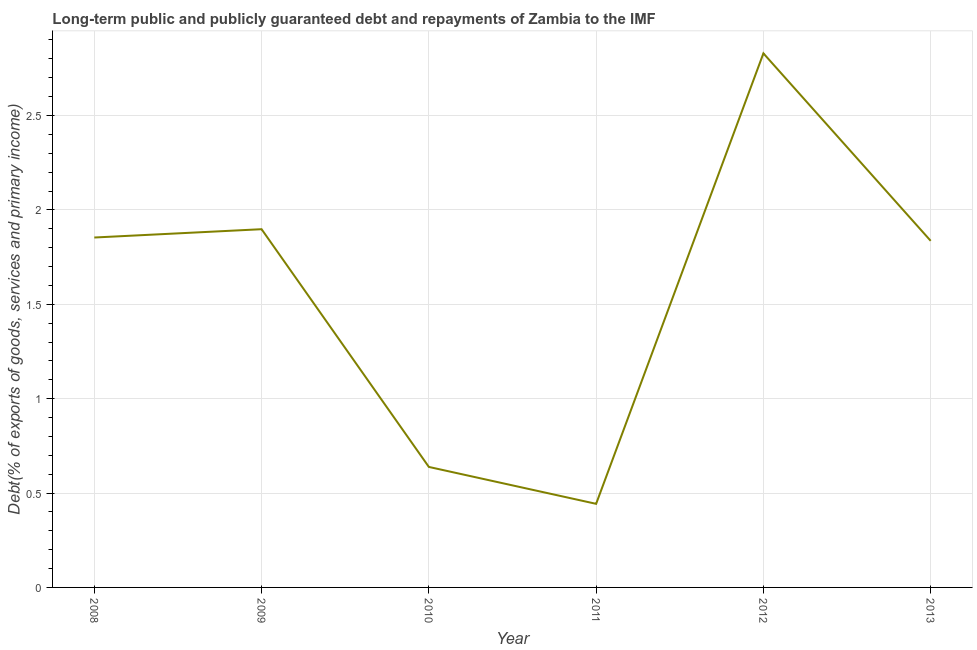What is the debt service in 2011?
Ensure brevity in your answer.  0.44. Across all years, what is the maximum debt service?
Your response must be concise. 2.83. Across all years, what is the minimum debt service?
Make the answer very short. 0.44. In which year was the debt service maximum?
Offer a terse response. 2012. What is the sum of the debt service?
Offer a terse response. 9.5. What is the difference between the debt service in 2011 and 2012?
Make the answer very short. -2.39. What is the average debt service per year?
Provide a short and direct response. 1.58. What is the median debt service?
Offer a very short reply. 1.84. Do a majority of the years between 2009 and 2008 (inclusive) have debt service greater than 0.1 %?
Give a very brief answer. No. What is the ratio of the debt service in 2008 to that in 2012?
Provide a short and direct response. 0.66. Is the debt service in 2010 less than that in 2012?
Make the answer very short. Yes. Is the difference between the debt service in 2009 and 2011 greater than the difference between any two years?
Your answer should be very brief. No. What is the difference between the highest and the second highest debt service?
Your response must be concise. 0.93. Is the sum of the debt service in 2010 and 2013 greater than the maximum debt service across all years?
Give a very brief answer. No. What is the difference between the highest and the lowest debt service?
Your answer should be compact. 2.39. In how many years, is the debt service greater than the average debt service taken over all years?
Make the answer very short. 4. How many years are there in the graph?
Provide a short and direct response. 6. Are the values on the major ticks of Y-axis written in scientific E-notation?
Your response must be concise. No. Does the graph contain grids?
Provide a succinct answer. Yes. What is the title of the graph?
Your answer should be compact. Long-term public and publicly guaranteed debt and repayments of Zambia to the IMF. What is the label or title of the Y-axis?
Keep it short and to the point. Debt(% of exports of goods, services and primary income). What is the Debt(% of exports of goods, services and primary income) of 2008?
Keep it short and to the point. 1.85. What is the Debt(% of exports of goods, services and primary income) of 2009?
Give a very brief answer. 1.9. What is the Debt(% of exports of goods, services and primary income) of 2010?
Give a very brief answer. 0.64. What is the Debt(% of exports of goods, services and primary income) of 2011?
Keep it short and to the point. 0.44. What is the Debt(% of exports of goods, services and primary income) of 2012?
Your response must be concise. 2.83. What is the Debt(% of exports of goods, services and primary income) in 2013?
Provide a succinct answer. 1.84. What is the difference between the Debt(% of exports of goods, services and primary income) in 2008 and 2009?
Give a very brief answer. -0.04. What is the difference between the Debt(% of exports of goods, services and primary income) in 2008 and 2010?
Your answer should be very brief. 1.22. What is the difference between the Debt(% of exports of goods, services and primary income) in 2008 and 2011?
Your answer should be compact. 1.41. What is the difference between the Debt(% of exports of goods, services and primary income) in 2008 and 2012?
Provide a short and direct response. -0.98. What is the difference between the Debt(% of exports of goods, services and primary income) in 2008 and 2013?
Provide a succinct answer. 0.02. What is the difference between the Debt(% of exports of goods, services and primary income) in 2009 and 2010?
Offer a very short reply. 1.26. What is the difference between the Debt(% of exports of goods, services and primary income) in 2009 and 2011?
Keep it short and to the point. 1.45. What is the difference between the Debt(% of exports of goods, services and primary income) in 2009 and 2012?
Offer a very short reply. -0.93. What is the difference between the Debt(% of exports of goods, services and primary income) in 2009 and 2013?
Your answer should be very brief. 0.06. What is the difference between the Debt(% of exports of goods, services and primary income) in 2010 and 2011?
Ensure brevity in your answer.  0.2. What is the difference between the Debt(% of exports of goods, services and primary income) in 2010 and 2012?
Ensure brevity in your answer.  -2.19. What is the difference between the Debt(% of exports of goods, services and primary income) in 2010 and 2013?
Provide a short and direct response. -1.2. What is the difference between the Debt(% of exports of goods, services and primary income) in 2011 and 2012?
Make the answer very short. -2.39. What is the difference between the Debt(% of exports of goods, services and primary income) in 2011 and 2013?
Make the answer very short. -1.39. What is the difference between the Debt(% of exports of goods, services and primary income) in 2012 and 2013?
Offer a very short reply. 0.99. What is the ratio of the Debt(% of exports of goods, services and primary income) in 2008 to that in 2010?
Offer a terse response. 2.9. What is the ratio of the Debt(% of exports of goods, services and primary income) in 2008 to that in 2011?
Keep it short and to the point. 4.19. What is the ratio of the Debt(% of exports of goods, services and primary income) in 2008 to that in 2012?
Offer a very short reply. 0.66. What is the ratio of the Debt(% of exports of goods, services and primary income) in 2008 to that in 2013?
Your answer should be compact. 1.01. What is the ratio of the Debt(% of exports of goods, services and primary income) in 2009 to that in 2010?
Your answer should be very brief. 2.97. What is the ratio of the Debt(% of exports of goods, services and primary income) in 2009 to that in 2011?
Your answer should be very brief. 4.29. What is the ratio of the Debt(% of exports of goods, services and primary income) in 2009 to that in 2012?
Your answer should be very brief. 0.67. What is the ratio of the Debt(% of exports of goods, services and primary income) in 2009 to that in 2013?
Provide a short and direct response. 1.03. What is the ratio of the Debt(% of exports of goods, services and primary income) in 2010 to that in 2011?
Give a very brief answer. 1.44. What is the ratio of the Debt(% of exports of goods, services and primary income) in 2010 to that in 2012?
Provide a succinct answer. 0.23. What is the ratio of the Debt(% of exports of goods, services and primary income) in 2010 to that in 2013?
Give a very brief answer. 0.35. What is the ratio of the Debt(% of exports of goods, services and primary income) in 2011 to that in 2012?
Your answer should be very brief. 0.16. What is the ratio of the Debt(% of exports of goods, services and primary income) in 2011 to that in 2013?
Provide a short and direct response. 0.24. What is the ratio of the Debt(% of exports of goods, services and primary income) in 2012 to that in 2013?
Offer a terse response. 1.54. 